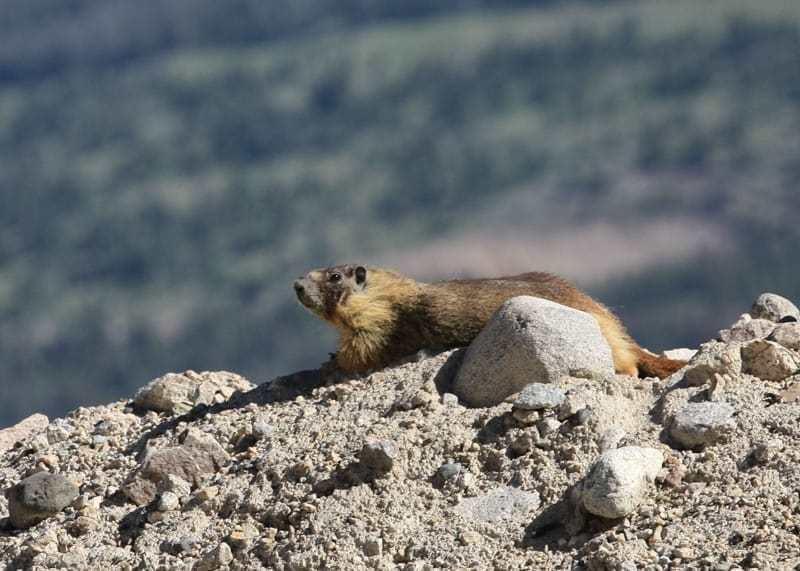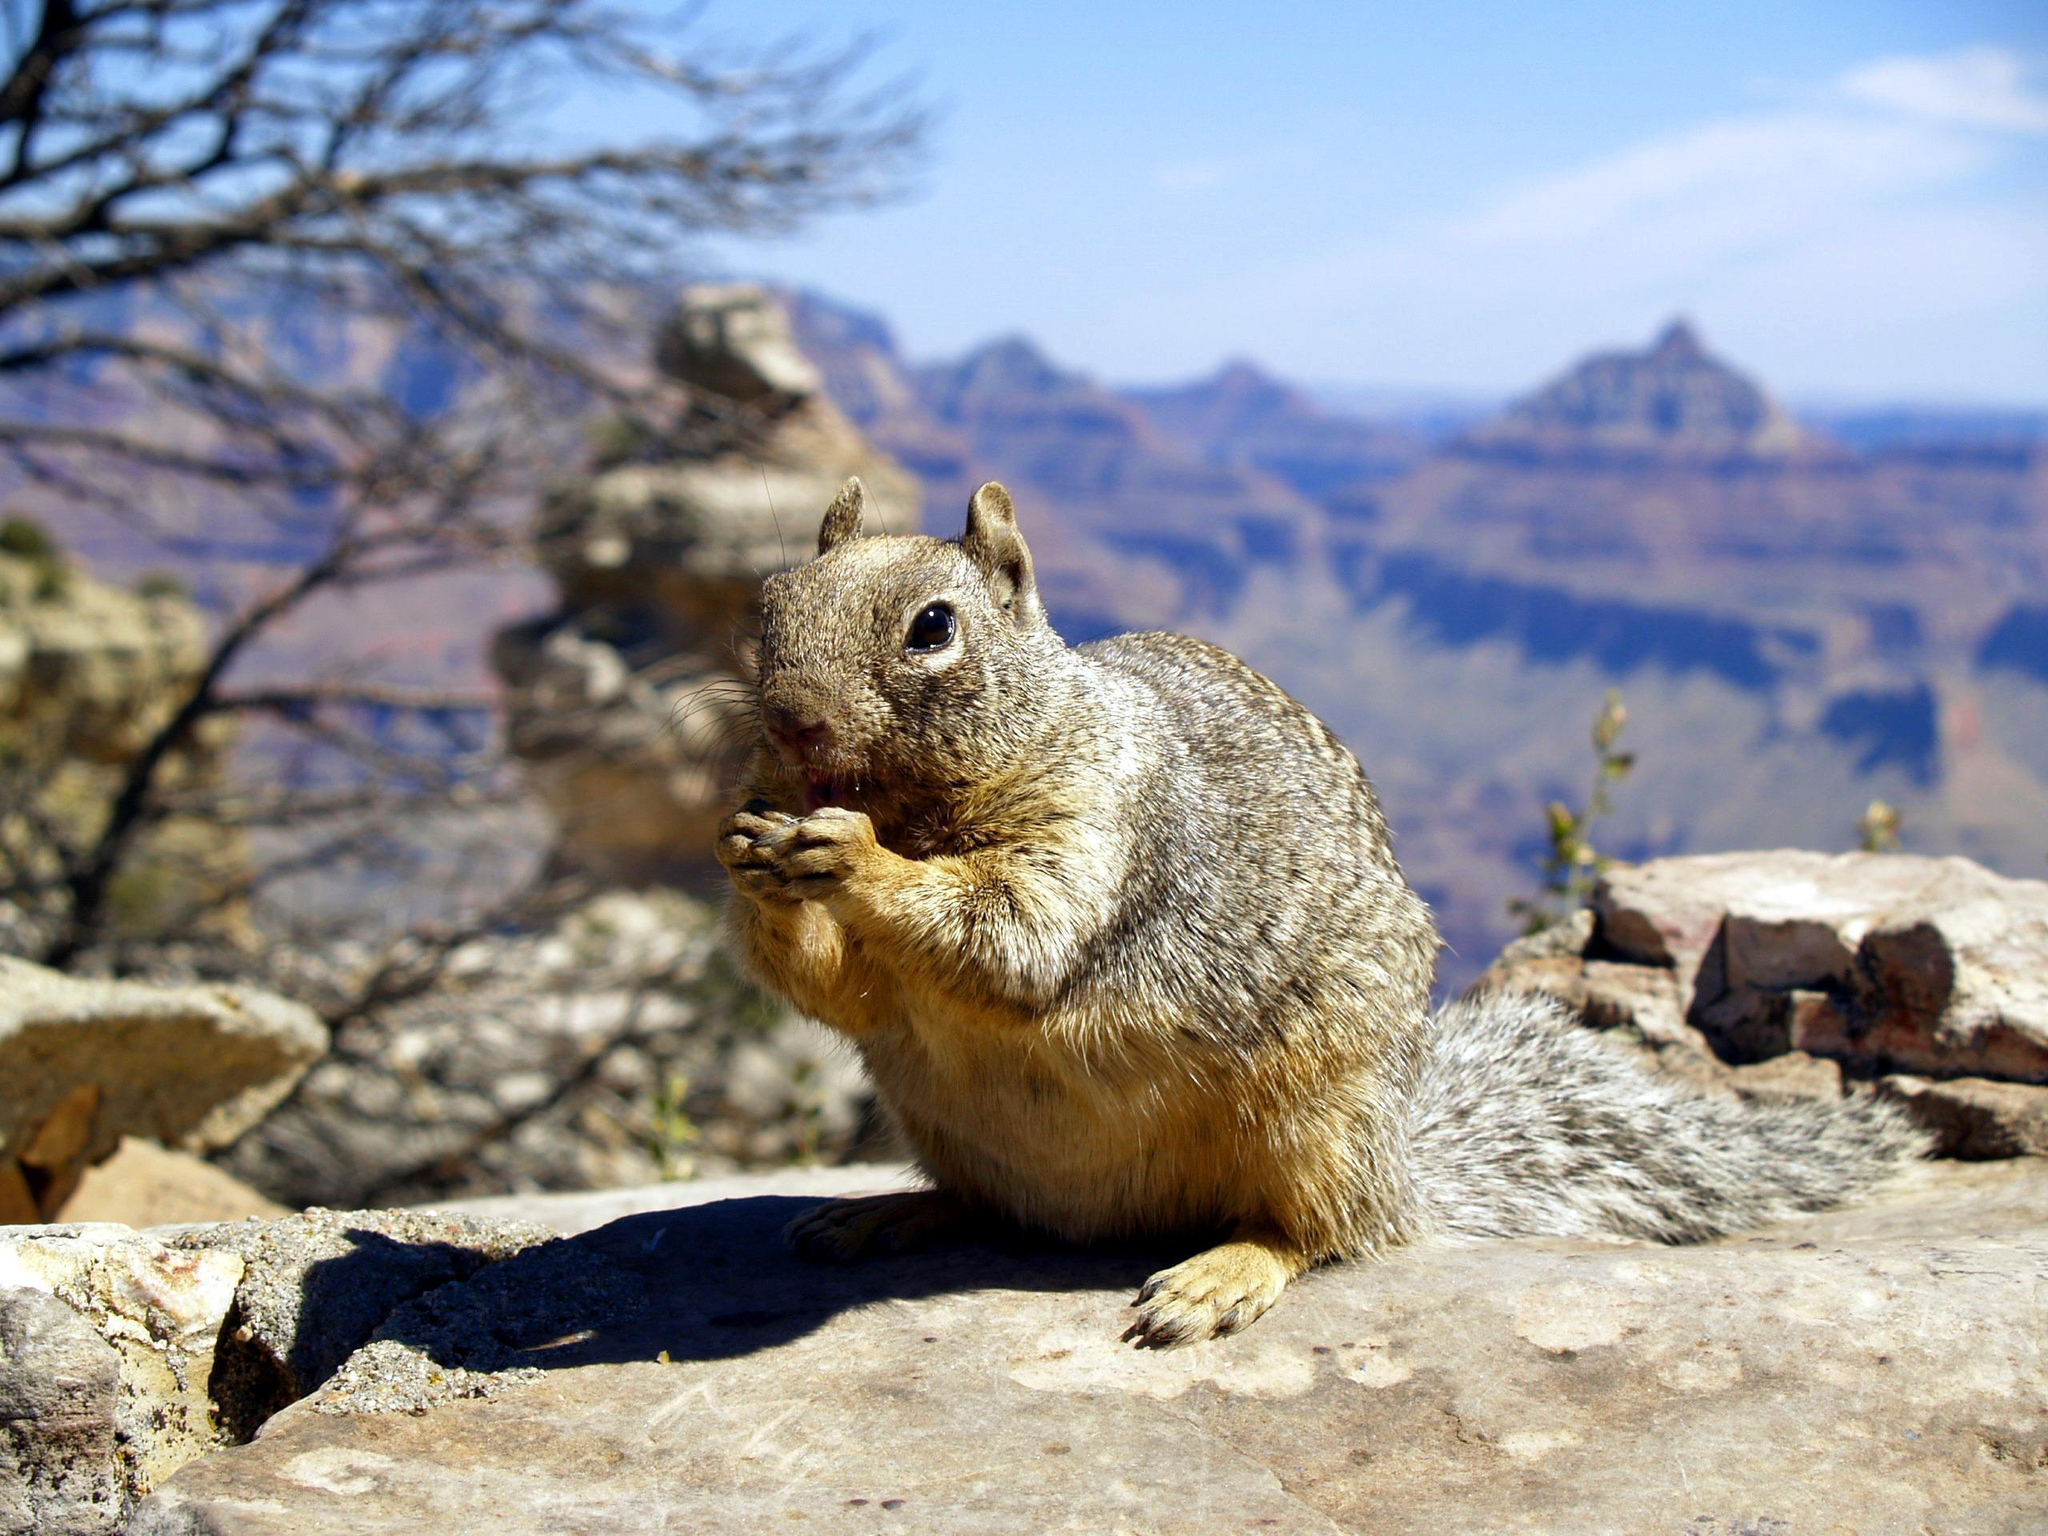The first image is the image on the left, the second image is the image on the right. Assess this claim about the two images: "The animal in the image on the left is facing left.". Correct or not? Answer yes or no. Yes. 